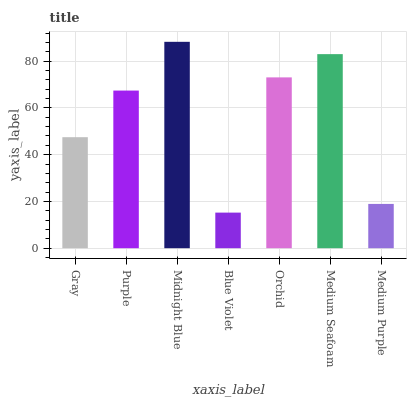Is Blue Violet the minimum?
Answer yes or no. Yes. Is Midnight Blue the maximum?
Answer yes or no. Yes. Is Purple the minimum?
Answer yes or no. No. Is Purple the maximum?
Answer yes or no. No. Is Purple greater than Gray?
Answer yes or no. Yes. Is Gray less than Purple?
Answer yes or no. Yes. Is Gray greater than Purple?
Answer yes or no. No. Is Purple less than Gray?
Answer yes or no. No. Is Purple the high median?
Answer yes or no. Yes. Is Purple the low median?
Answer yes or no. Yes. Is Medium Purple the high median?
Answer yes or no. No. Is Medium Seafoam the low median?
Answer yes or no. No. 